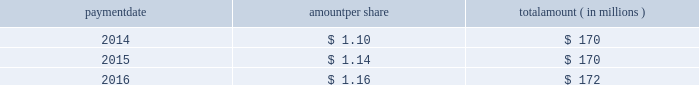Humana inc .
Notes to consolidated financial statements 2014 ( continued ) 15 .
Stockholders 2019 equity as discussed in note 2 , we elected to early adopt new guidance related to accounting for employee share-based payments prospectively effective january 1 , 2016 .
The adoption of this new guidance resulted in the recognition of approximately $ 20 million of tax benefits in net income in our consolidated statement of income for the three months ended march 31 , 2016 that had previously been recorded as additional paid-in capital in our consolidated balance sheet .
Dividends the table provides details of dividend payments , excluding dividend equivalent rights , in 2014 , 2015 , and 2016 under our board approved quarterly cash dividend policy : payment amount per share amount ( in millions ) .
Under the terms of the merger agreement , we agreed with aetna that our quarterly dividend would not exceed $ 0.29 per share prior to the closing or termination of the merger .
On october 26 , 2016 , the board declared a cash dividend of $ 0.29 per share that was paid on january 27 , 2017 to stockholders of record on january 12 , 2017 , for an aggregate amount of $ 43 million .
On february 14 , 2017 , following the termination of the merger agreement , the board declared a cash dividend of $ 0.40 per share , to be paid on april 28 , 2017 , to the stockholders of record on march 31 , 2017 .
Declaration and payment of future quarterly dividends is at the discretion of our board and may be adjusted as business needs or market conditions change .
Stock repurchases in september 2014 , our board of directors replaced a previous share repurchase authorization of up to $ 1 billion ( of which $ 816 million remained unused ) with an authorization for repurchases of up to $ 2 billion of our common shares exclusive of shares repurchased in connection with employee stock plans , which expired on december 31 , 2016 .
Under the share repurchase authorization , shares may have been purchased from time to time at prevailing prices in the open market , by block purchases , through plans designed to comply with rule 10b5-1 under the securities exchange act of 1934 , as amended , or in privately-negotiated transactions ( including pursuant to accelerated share repurchase agreements with investment banks ) , subject to certain regulatory restrictions on volume , pricing , and timing .
Pursuant to the merger agreement , after july 2 , 2015 , we were prohibited from repurchasing any of our outstanding securities without the prior written consent of aetna , other than repurchases of shares of our common stock in connection with the exercise of outstanding stock options or the vesting or settlement of outstanding restricted stock awards .
Accordingly , as announced on july 3 , 2015 , we suspended our share repurchase program. .
What was the number of stockholders of record on january 12 , 2017 , for an aggregate amount of $ 43 million .? 
Computations: (43 / 0.29)
Answer: 148.27586. 